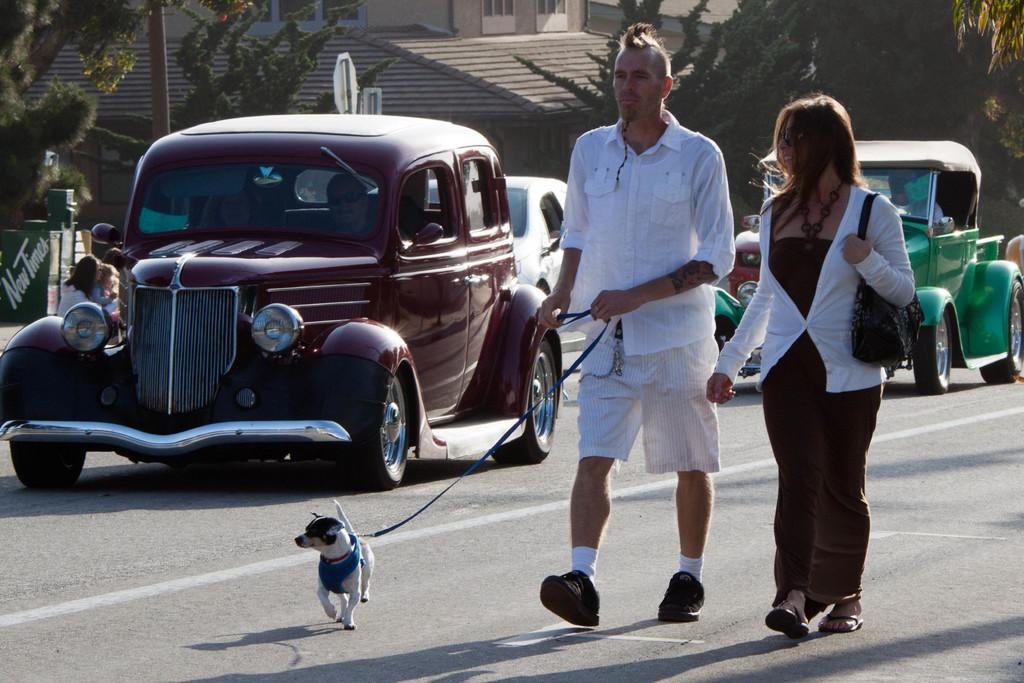How many subjects are present in the image? There are people and a dog in the image. What are the people and dog doing in the image? The people and dog are walking on a road. What can be seen in the background of the image? There is a building, trees, people, a pole, and some objects in the background of the image. What color are the dog's toes in the image? The image does not show the dog's toes, so we cannot determine their color. What type of bone is the dog holding in the image? There is no bone present in the image; it only features a dog and people walking on a road. 